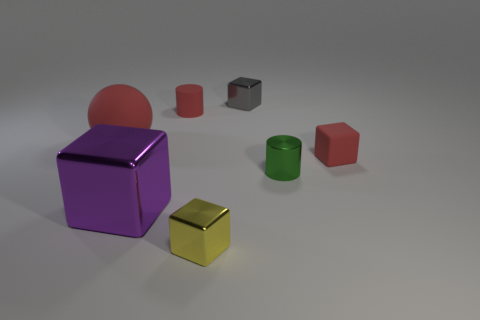Add 1 tiny shiny cylinders. How many objects exist? 8 Subtract all cylinders. How many objects are left? 5 Subtract all purple shiny cylinders. Subtract all large purple shiny blocks. How many objects are left? 6 Add 7 purple metallic blocks. How many purple metallic blocks are left? 8 Add 3 large purple metal cubes. How many large purple metal cubes exist? 4 Subtract 1 red cylinders. How many objects are left? 6 